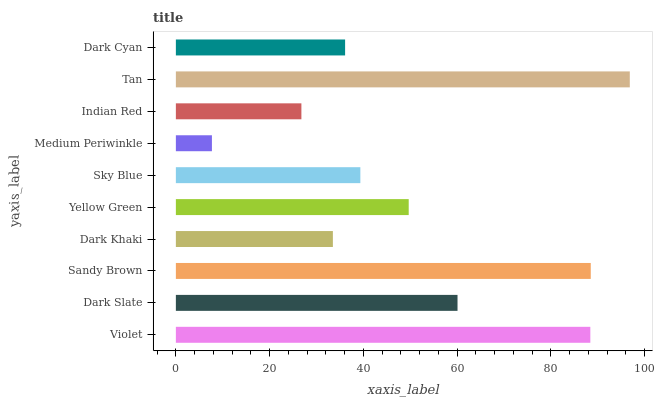Is Medium Periwinkle the minimum?
Answer yes or no. Yes. Is Tan the maximum?
Answer yes or no. Yes. Is Dark Slate the minimum?
Answer yes or no. No. Is Dark Slate the maximum?
Answer yes or no. No. Is Violet greater than Dark Slate?
Answer yes or no. Yes. Is Dark Slate less than Violet?
Answer yes or no. Yes. Is Dark Slate greater than Violet?
Answer yes or no. No. Is Violet less than Dark Slate?
Answer yes or no. No. Is Yellow Green the high median?
Answer yes or no. Yes. Is Sky Blue the low median?
Answer yes or no. Yes. Is Sandy Brown the high median?
Answer yes or no. No. Is Medium Periwinkle the low median?
Answer yes or no. No. 